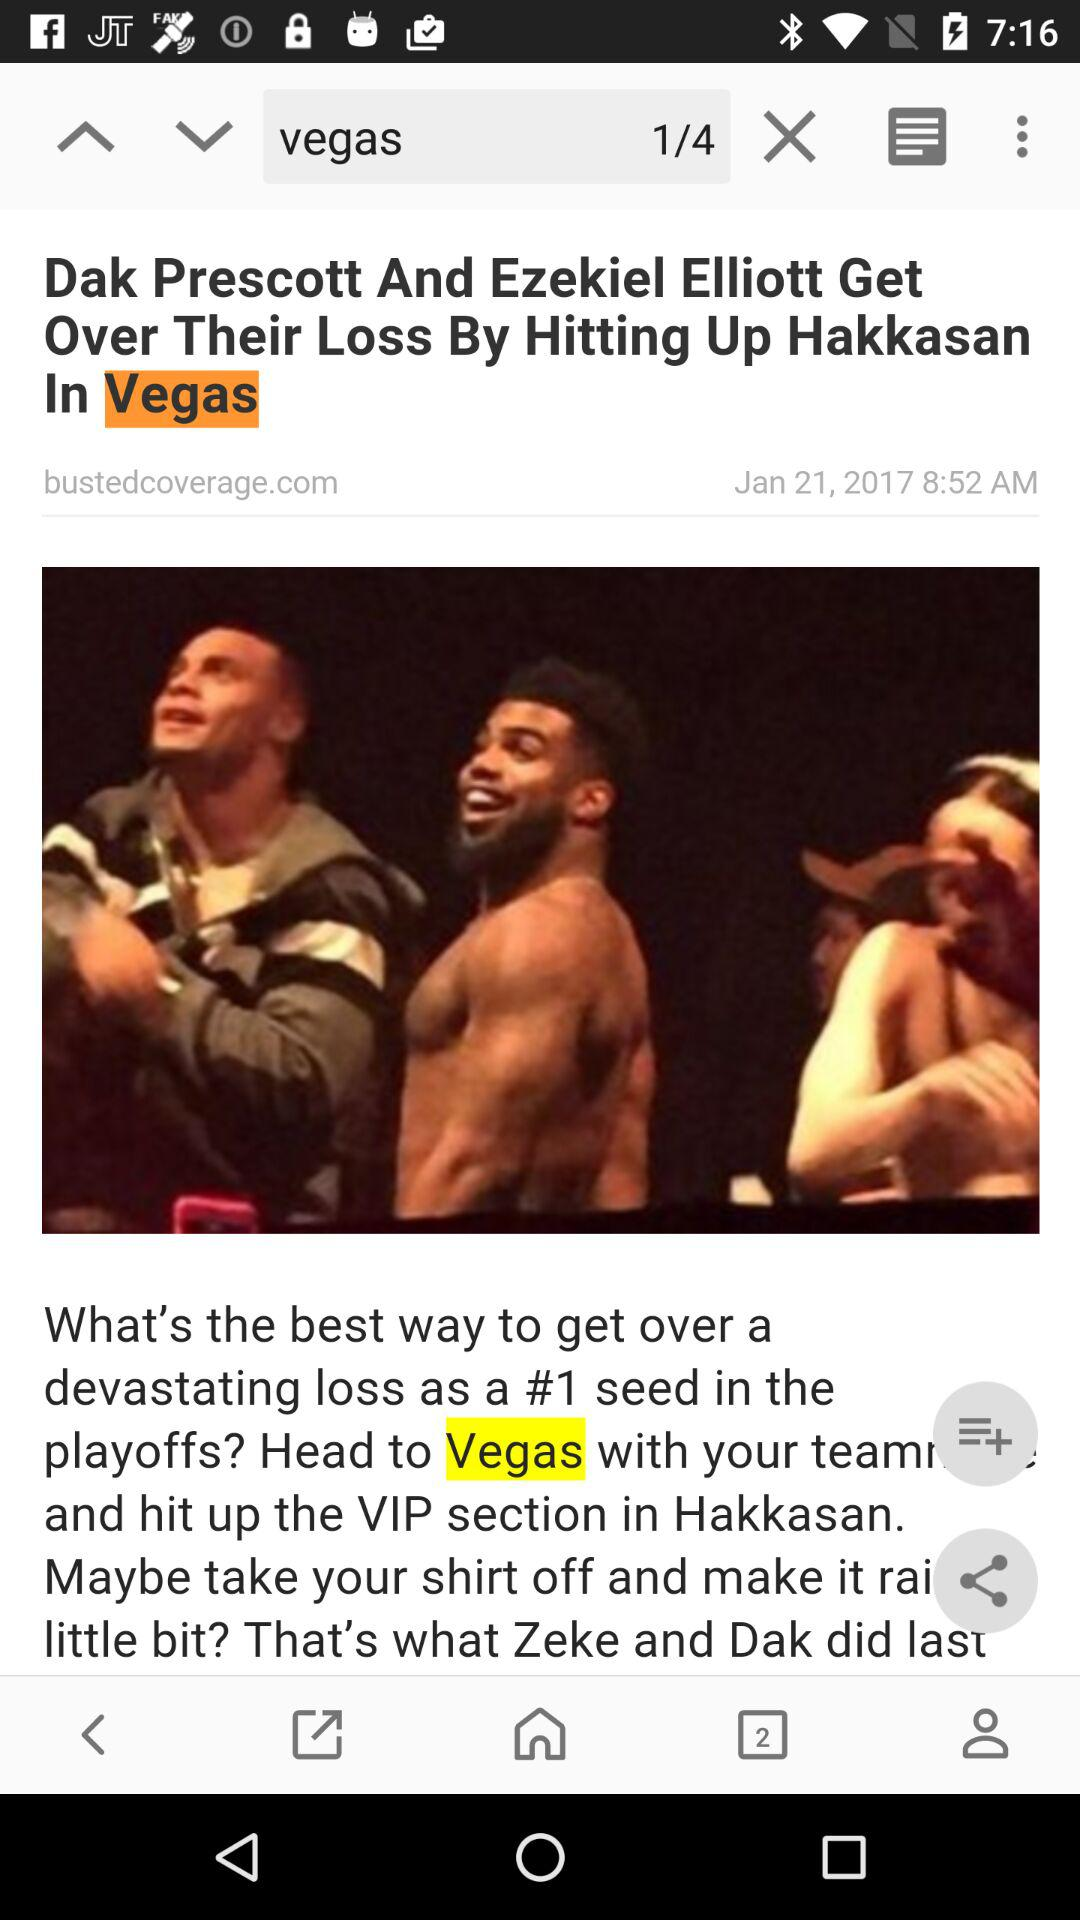Who posted the article? The article was posted by bustedcoverage.com. 